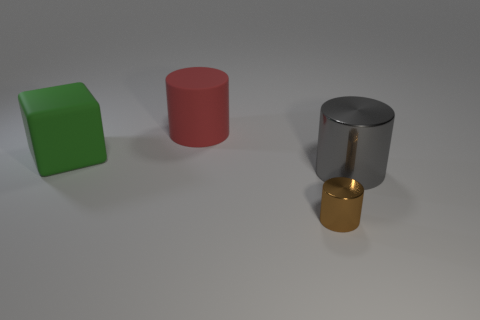How many gray things are either large metal cylinders or tiny rubber spheres?
Provide a succinct answer. 1. How many things are large objects or large cylinders to the right of the brown metal cylinder?
Your response must be concise. 3. What is the large red object that is behind the small brown cylinder made of?
Give a very brief answer. Rubber. There is a gray shiny object that is the same size as the red cylinder; what is its shape?
Give a very brief answer. Cylinder. Are there any brown rubber things of the same shape as the red rubber object?
Offer a very short reply. No. Does the green block have the same material as the cylinder in front of the big gray cylinder?
Keep it short and to the point. No. There is a thing behind the large thing that is left of the red rubber cylinder; what is it made of?
Provide a succinct answer. Rubber. Is the number of big shiny cylinders behind the big metal thing greater than the number of tiny things?
Your response must be concise. No. Are any small blue cylinders visible?
Your response must be concise. No. There is a object in front of the big metal cylinder; what color is it?
Provide a succinct answer. Brown. 